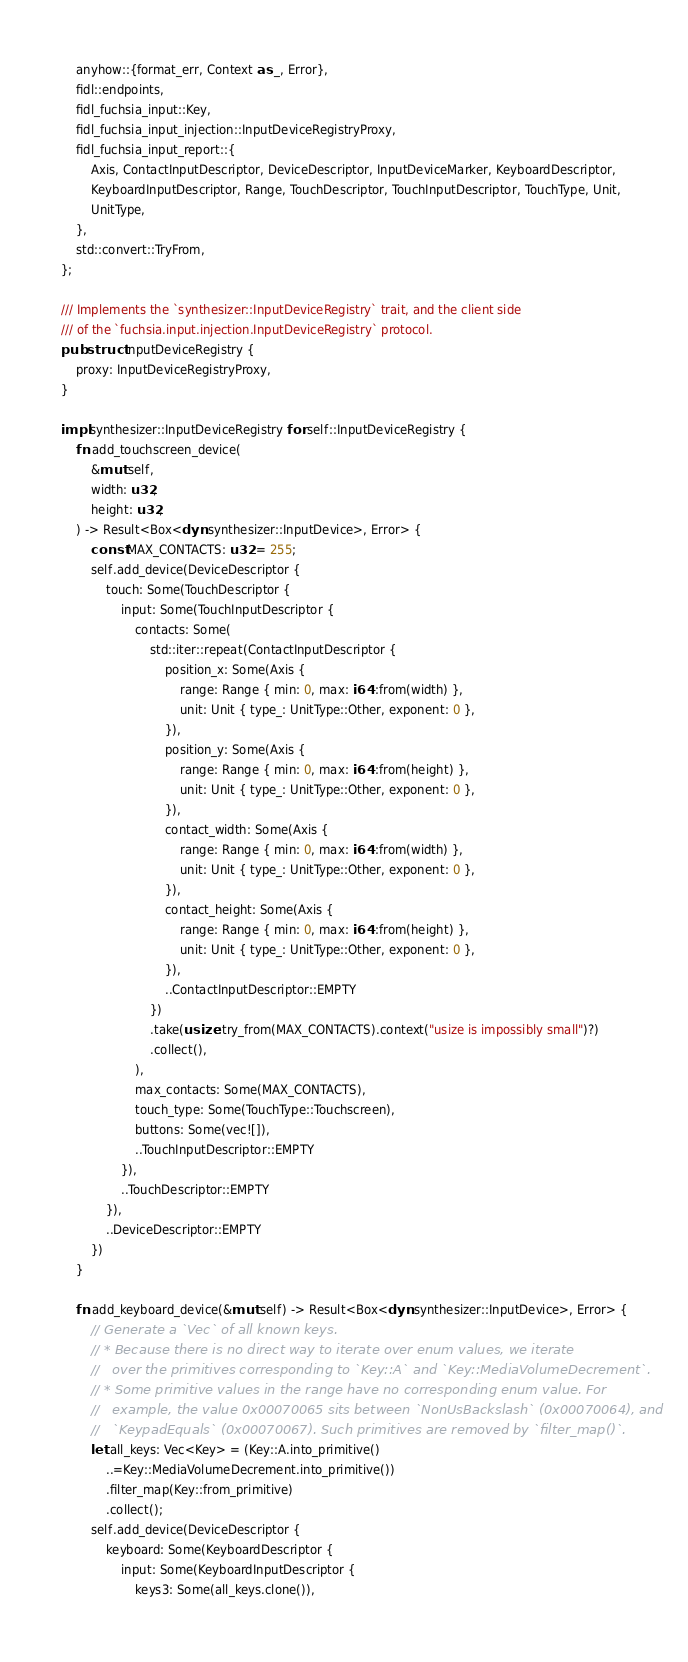Convert code to text. <code><loc_0><loc_0><loc_500><loc_500><_Rust_>    anyhow::{format_err, Context as _, Error},
    fidl::endpoints,
    fidl_fuchsia_input::Key,
    fidl_fuchsia_input_injection::InputDeviceRegistryProxy,
    fidl_fuchsia_input_report::{
        Axis, ContactInputDescriptor, DeviceDescriptor, InputDeviceMarker, KeyboardDescriptor,
        KeyboardInputDescriptor, Range, TouchDescriptor, TouchInputDescriptor, TouchType, Unit,
        UnitType,
    },
    std::convert::TryFrom,
};

/// Implements the `synthesizer::InputDeviceRegistry` trait, and the client side
/// of the `fuchsia.input.injection.InputDeviceRegistry` protocol.
pub struct InputDeviceRegistry {
    proxy: InputDeviceRegistryProxy,
}

impl synthesizer::InputDeviceRegistry for self::InputDeviceRegistry {
    fn add_touchscreen_device(
        &mut self,
        width: u32,
        height: u32,
    ) -> Result<Box<dyn synthesizer::InputDevice>, Error> {
        const MAX_CONTACTS: u32 = 255;
        self.add_device(DeviceDescriptor {
            touch: Some(TouchDescriptor {
                input: Some(TouchInputDescriptor {
                    contacts: Some(
                        std::iter::repeat(ContactInputDescriptor {
                            position_x: Some(Axis {
                                range: Range { min: 0, max: i64::from(width) },
                                unit: Unit { type_: UnitType::Other, exponent: 0 },
                            }),
                            position_y: Some(Axis {
                                range: Range { min: 0, max: i64::from(height) },
                                unit: Unit { type_: UnitType::Other, exponent: 0 },
                            }),
                            contact_width: Some(Axis {
                                range: Range { min: 0, max: i64::from(width) },
                                unit: Unit { type_: UnitType::Other, exponent: 0 },
                            }),
                            contact_height: Some(Axis {
                                range: Range { min: 0, max: i64::from(height) },
                                unit: Unit { type_: UnitType::Other, exponent: 0 },
                            }),
                            ..ContactInputDescriptor::EMPTY
                        })
                        .take(usize::try_from(MAX_CONTACTS).context("usize is impossibly small")?)
                        .collect(),
                    ),
                    max_contacts: Some(MAX_CONTACTS),
                    touch_type: Some(TouchType::Touchscreen),
                    buttons: Some(vec![]),
                    ..TouchInputDescriptor::EMPTY
                }),
                ..TouchDescriptor::EMPTY
            }),
            ..DeviceDescriptor::EMPTY
        })
    }

    fn add_keyboard_device(&mut self) -> Result<Box<dyn synthesizer::InputDevice>, Error> {
        // Generate a `Vec` of all known keys.
        // * Because there is no direct way to iterate over enum values, we iterate
        //   over the primitives corresponding to `Key::A` and `Key::MediaVolumeDecrement`.
        // * Some primitive values in the range have no corresponding enum value. For
        //   example, the value 0x00070065 sits between `NonUsBackslash` (0x00070064), and
        //   `KeypadEquals` (0x00070067). Such primitives are removed by `filter_map()`.
        let all_keys: Vec<Key> = (Key::A.into_primitive()
            ..=Key::MediaVolumeDecrement.into_primitive())
            .filter_map(Key::from_primitive)
            .collect();
        self.add_device(DeviceDescriptor {
            keyboard: Some(KeyboardDescriptor {
                input: Some(KeyboardInputDescriptor {
                    keys3: Some(all_keys.clone()),</code> 